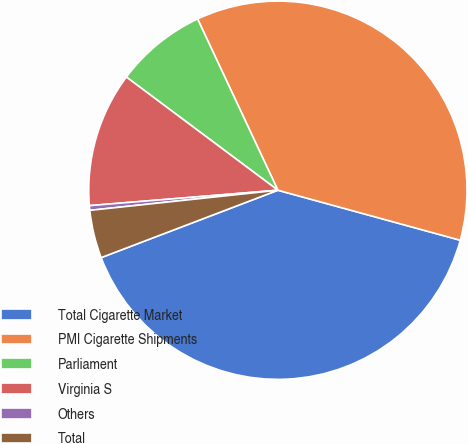Convert chart. <chart><loc_0><loc_0><loc_500><loc_500><pie_chart><fcel>Total Cigarette Market<fcel>PMI Cigarette Shipments<fcel>Parliament<fcel>Virginia S<fcel>Others<fcel>Total<nl><fcel>39.94%<fcel>36.24%<fcel>7.81%<fcel>11.51%<fcel>0.4%<fcel>4.1%<nl></chart> 